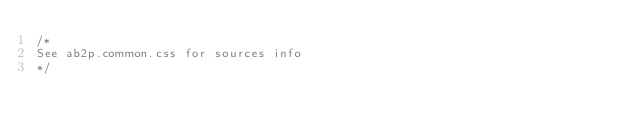Convert code to text. <code><loc_0><loc_0><loc_500><loc_500><_CSS_>/*
See ab2p.common.css for sources info
*/</code> 